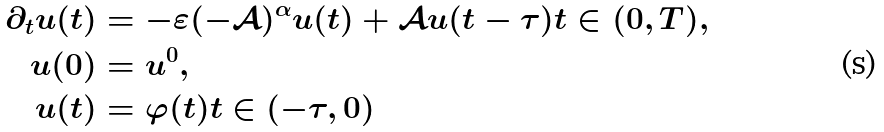Convert formula to latex. <formula><loc_0><loc_0><loc_500><loc_500>\partial _ { t } u ( t ) & = - \varepsilon ( - \mathcal { A } ) ^ { \alpha } u ( t ) + \mathcal { A } u ( t - \tau ) t \in ( 0 , T ) , \\ u ( 0 ) & = u ^ { 0 } , \\ u ( t ) & = \varphi ( t ) t \in ( - \tau , 0 )</formula> 